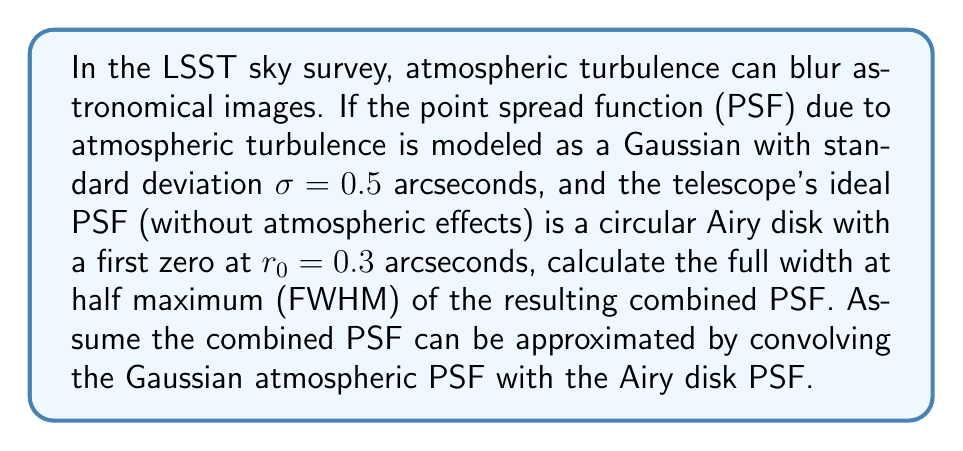What is the answer to this math problem? To solve this problem, we'll follow these steps:

1) First, recall that the convolution of two functions in the spatial domain is equivalent to multiplication in the Fourier domain.

2) The Fourier transform of a Gaussian function with standard deviation $\sigma$ is another Gaussian with standard deviation $1/(2\pi\sigma)$.

3) The Fourier transform of an Airy disk is a circular top-hat function.

4) The FWHM of a Gaussian is related to its standard deviation by: $FWHM_{Gaussian} = 2\sqrt{2\ln(2)}\sigma \approx 2.355\sigma$.

5) For the Airy disk, the FWHM can be approximated as $FWHM_{Airy} \approx 0.705r_0$.

6) The combined PSF will have a FWHM that can be approximated by adding the squares of the individual FWHMs in quadrature:

   $$FWHM_{combined} = \sqrt{FWHM_{Gaussian}^2 + FWHM_{Airy}^2}$$

7) Let's calculate:
   
   $FWHM_{Gaussian} = 2.355 * 0.5 = 1.1775$ arcseconds
   
   $FWHM_{Airy} = 0.705 * 0.3 = 0.2115$ arcseconds

8) Now, we can compute the combined FWHM:

   $$FWHM_{combined} = \sqrt{1.1775^2 + 0.2115^2} = \sqrt{1.3865 + 0.0447} = \sqrt{1.4312} \approx 1.1963$$ arcseconds
Answer: The FWHM of the combined PSF is approximately 1.20 arcseconds. 